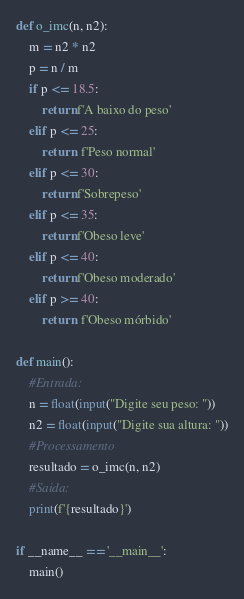<code> <loc_0><loc_0><loc_500><loc_500><_Python_>def o_imc(n, n2):
    m = n2 * n2
    p = n / m
    if p <= 18.5:
        return f'A baixo do peso'
    elif p <= 25:
        return  f'Peso normal'
    elif p <= 30:
        return f'Sobrepeso'
    elif p <= 35:
        return f'Obeso leve'
    elif p <= 40:
        return f'Obeso moderado'
    elif p >= 40:
        return  f'Obeso mórbido'

def main():
    #Entrada:
    n = float(input("Digite seu peso: "))
    n2 = float(input("Digite sua altura: "))
    #Processamento
    resultado = o_imc(n, n2)
    #Saida:
    print(f'{resultado}')

if __name__ == '__main__':
    main()</code> 